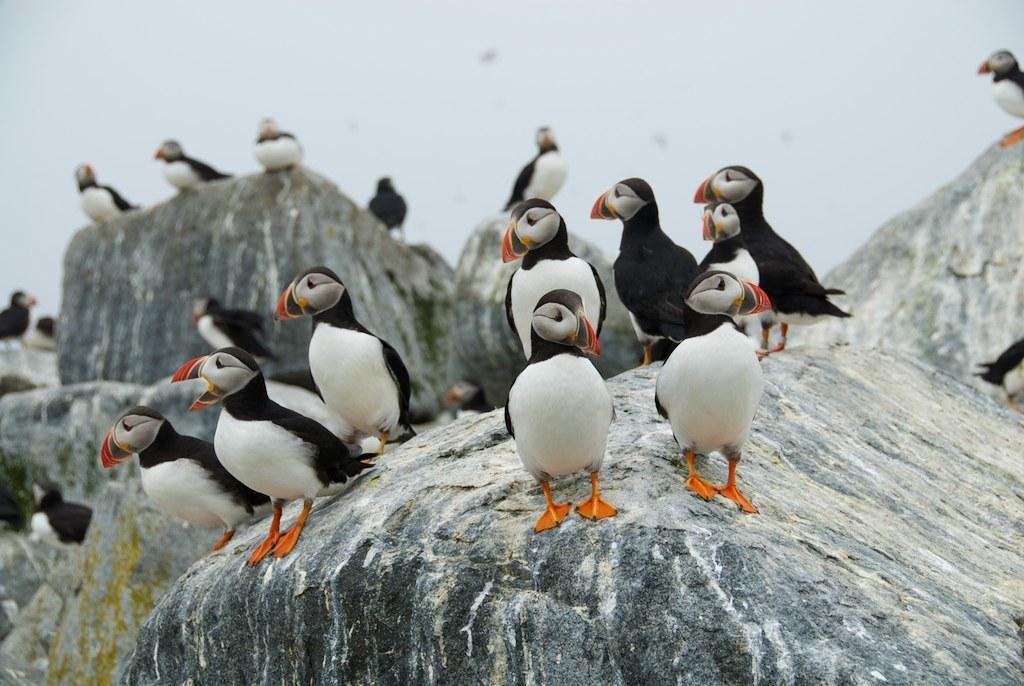Please provide a concise description of this image. In this image I can see there is a baby penguin. And at the top there is a sky. 